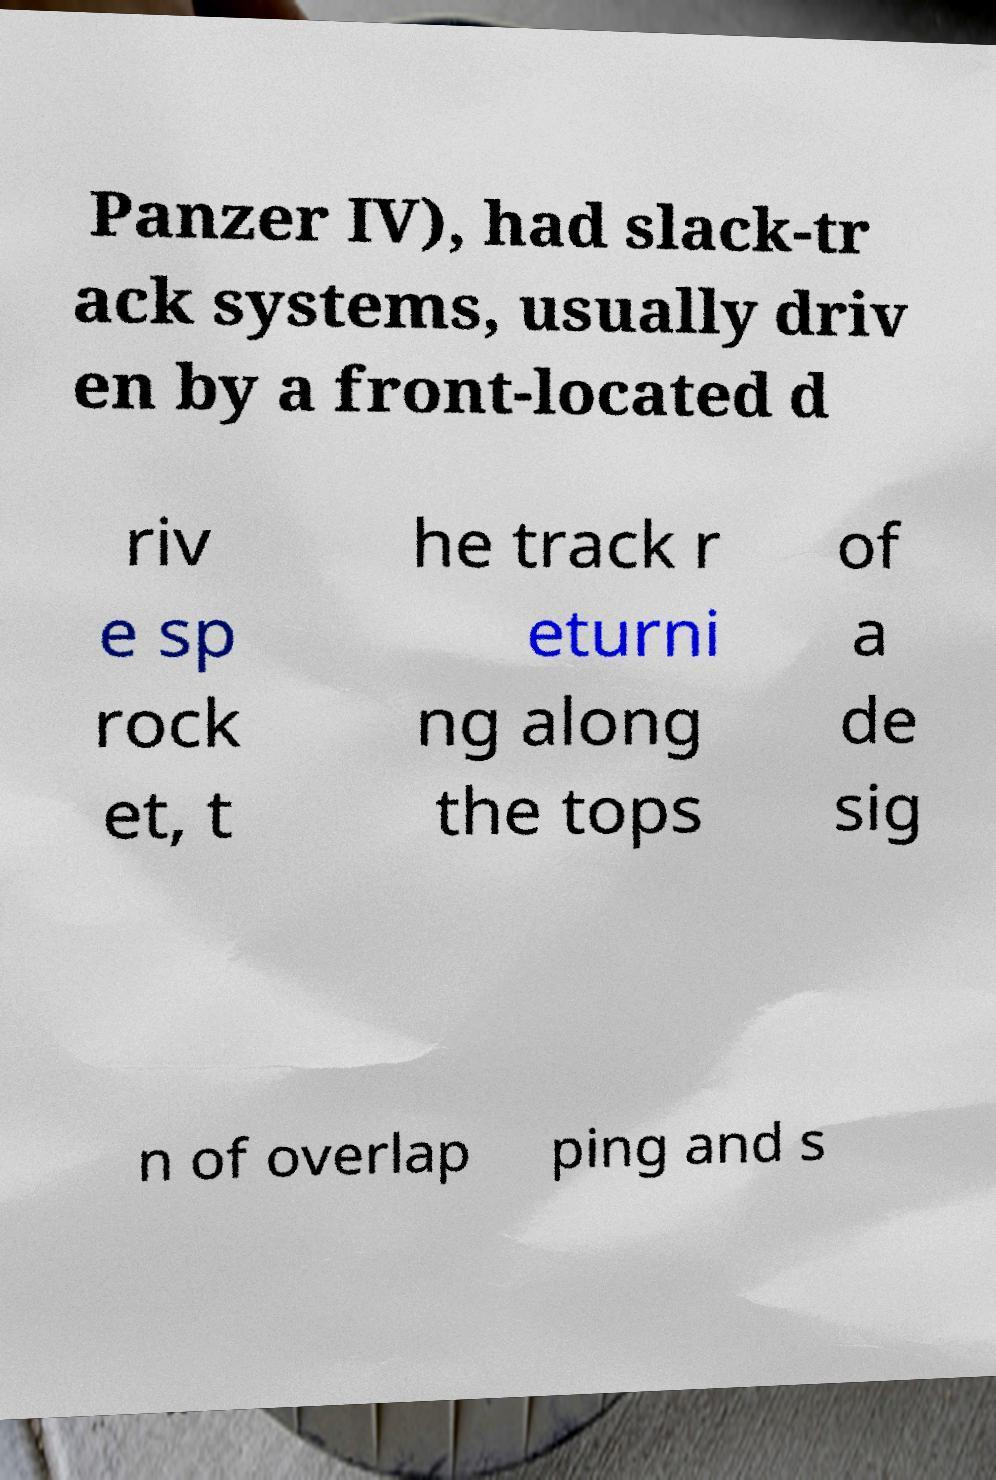What messages or text are displayed in this image? I need them in a readable, typed format. Panzer IV), had slack-tr ack systems, usually driv en by a front-located d riv e sp rock et, t he track r eturni ng along the tops of a de sig n of overlap ping and s 